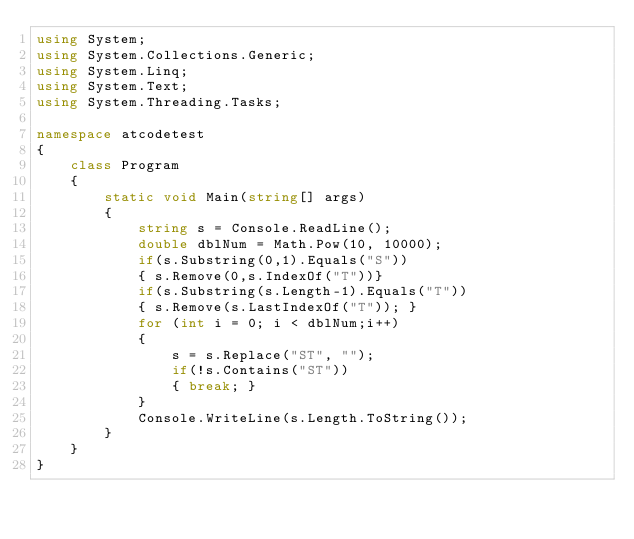Convert code to text. <code><loc_0><loc_0><loc_500><loc_500><_C#_>using System;
using System.Collections.Generic;
using System.Linq;
using System.Text;
using System.Threading.Tasks;

namespace atcodetest
{
    class Program
    {
        static void Main(string[] args)
        {
            string s = Console.ReadLine();
            double dblNum = Math.Pow(10, 10000);
            if(s.Substring(0,1).Equals("S"))
            { s.Remove(0,s.IndexOf("T"))}
            if(s.Substring(s.Length-1).Equals("T"))
            { s.Remove(s.LastIndexOf("T")); }
            for (int i = 0; i < dblNum;i++)
            {
                s = s.Replace("ST", "");
                if(!s.Contains("ST"))
                { break; }
            }
            Console.WriteLine(s.Length.ToString());
        }
    }
}</code> 